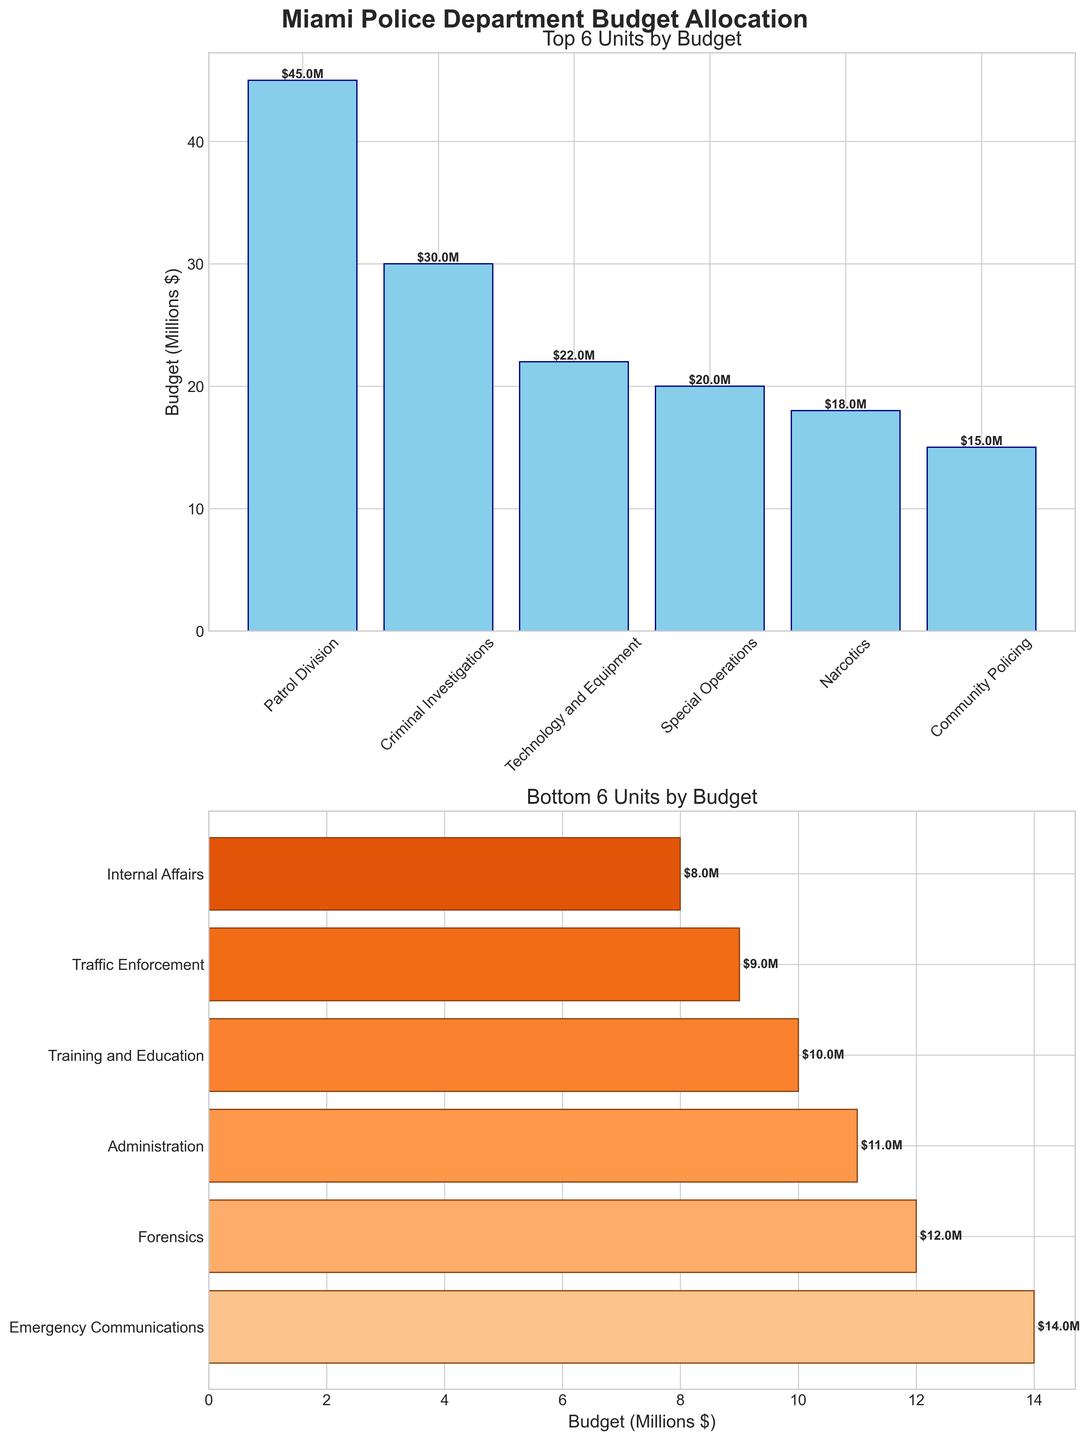How many units have their budget allocations represented in the top 6 units by budget chart? The chart titled "Top 6 Units by Budget" represents 6 units with the highest budget allocations.
Answer: 6 Which unit has the highest budget allocation? The bar chart shows the Patrol Division as having the highest bar within the "Top 6 Units by Budget" section.
Answer: Patrol Division What is the budget allocation for the Forensics unit? The bar for the Forensics unit is present in the "Bottom 6 Units by Budget" chart with a label showing $12M.
Answer: $12M Which unit has a higher budget allocation: Technology and Equipment or Narcotics? In the "Top 6 Units by Budget" chart, both Technology and Equipment and Narcotics are present. The bar for Technology and Equipment is higher, showing $22M compared to $18M for Narcotics.
Answer: Technology and Equipment What is the average budget allocation for the top 3 units by budget? The top 3 units by budget are Patrol Division ($45M), Criminal Investigations ($30M), and Special Operations ($20M). Summing these gives $95M. The average is $95M / 3 = $31.7M.
Answer: $31.7M What is the combined budget allocation for the Community Policing and Training and Education units? The "Bottom 6 Units by Budget" chart shows Community Policing at $15M and Training and Education at $10M. Adding these gives $15M + $10M = $25M.
Answer: $25M Which unit has the lowest budget allocation and what is its amount? The lowest budget allocation is shown in the "Bottom 6 Units by Budget" chart for Internal Affairs with $8M.
Answer: Internal Affairs, $8M Are there more units in the bottom 6 section with budgets higher than $10M or lower than $10M? In the "Bottom 6 Units by Budget" chart, Forensics ($12M), Community Policing ($15M), Training and Education ($10M), and Emergency Communications ($14M) are higher than $10M, while Internal Affairs ($8M) and Traffic Enforcement ($9M) are lower. There are four units higher and two lower.
Answer: Higher What is the difference in budget allocation between the Patrol Division and Special Operations units? The Patrol Division's budget is $45M and Special Operations’ budget is $20M. The difference is $45M - $20M = $25M.
Answer: $25M Which chart shows the budget allocation for the Emergency Communications unit? The Emergency Communications unit is shown in the "Bottom 6 Units by Budget" chart.
Answer: "Bottom 6 Units by Budget" 